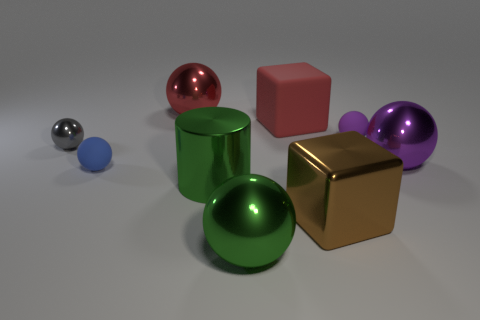Is the large red thing in front of the red sphere made of the same material as the gray object?
Your response must be concise. No. Are there more tiny gray objects that are in front of the tiny purple sphere than large red spheres in front of the large red matte block?
Offer a very short reply. Yes. What is the size of the green ball?
Your answer should be compact. Large. There is a red object that is made of the same material as the blue sphere; what shape is it?
Offer a very short reply. Cube. Is the shape of the red object to the right of the red ball the same as  the gray metal thing?
Make the answer very short. No. How many objects are either brown rubber things or gray metal objects?
Offer a terse response. 1. What material is the ball that is behind the gray shiny object and right of the green ball?
Ensure brevity in your answer.  Rubber. Is the gray sphere the same size as the purple metal object?
Provide a short and direct response. No. What is the size of the purple thing that is on the left side of the large metallic ball that is on the right side of the green ball?
Keep it short and to the point. Small. What number of shiny objects are both right of the red matte thing and behind the large red matte block?
Keep it short and to the point. 0. 